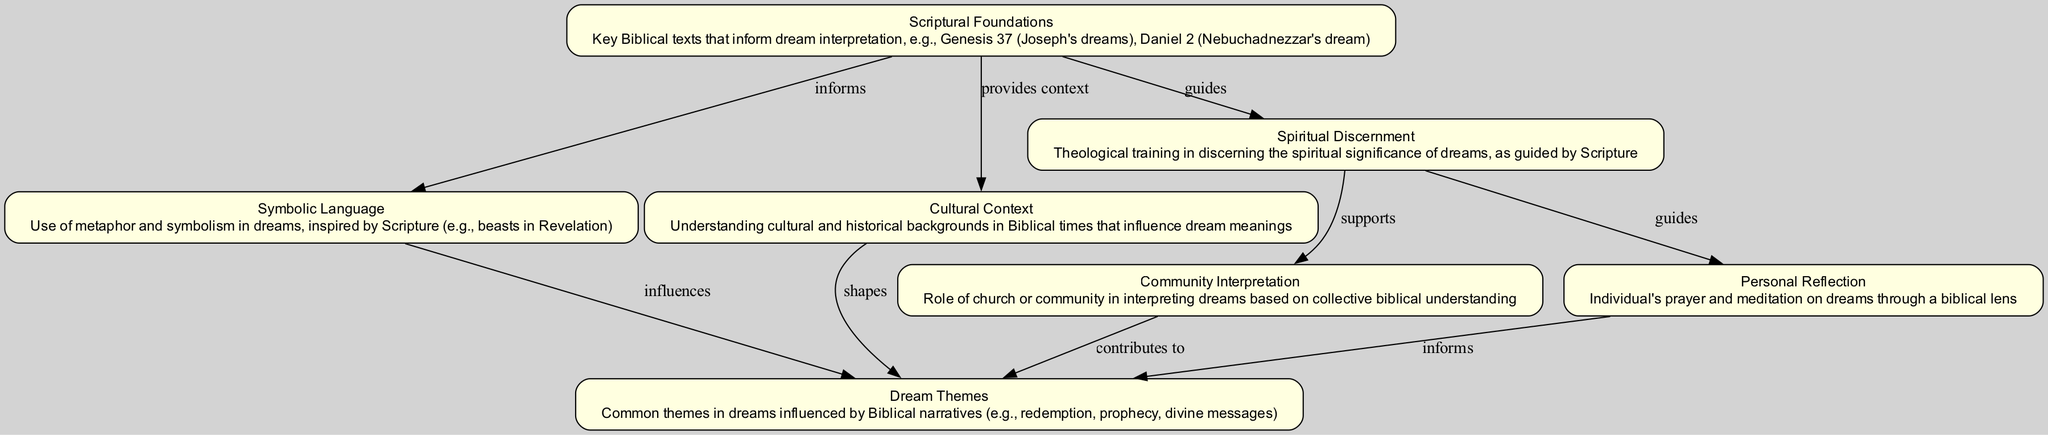What are the key Biblical texts mentioned in the diagram? The diagram identifies "Genesis 37 (Joseph's dreams), Daniel 2 (Nebuchadnezzar's dream)" under the "Scriptural Foundations" node as key Biblical texts that inform dream interpretation.
Answer: Genesis 37, Daniel 2 How many nodes are present in the diagram? By counting the individual elements defined in the data, there are seven distinct nodes present in the diagram that represent different aspects of the influence of Scripture on dream content and interpretation.
Answer: 7 Which node informs the "Symbolic Language" node? According to the flow of the diagram, the "Scriptural Foundations" node has a directed edge to the "Symbolic Language" node indicating that it informs this aspect.
Answer: Scriptural Foundations What does the "Community Interpretation" node contribute to? The diagram shows that the "Community Interpretation" node has a directed edge leading to the "Dream Themes" node, indicating that it contributes to understanding these themes based on collective biblical understanding.
Answer: Dream Themes Which node supports the "Community Interpretation" node? The "Spiritual Discernment" node has a directed edge leading to the "Community Interpretation" node, indicating that it supports the interpretation of dreams among a community based on biblical teachings.
Answer: Spiritual Discernment What influences the "Dream Themes" according to the diagram? The "Symbolic Language" node and the "Cultural Context" node both have directed edges toward the "Dream Themes" node, meaning they influence the themes found within dreams.
Answer: Symbolic Language, Cultural Context How is "Personal Reflection" related to "Dream Themes"? The diagram shows that "Personal Reflection" contributes to the "Dream Themes" through a directed edge, indicating that individual prayer and meditation inform the understanding of those themes.
Answer: informs What is the relationship between "Spiritual Discernment" and "Personal Reflection"? The diagram depicts that "Spiritual Discernment" guides "Personal Reflection", establishing a relationship where theological training helps inform individual contemplation on dreams.
Answer: guides How many directed edges are in the diagram? By reviewing the list of connections made between various nodes, there are a total of eight directed edges present in the diagram.
Answer: 8 